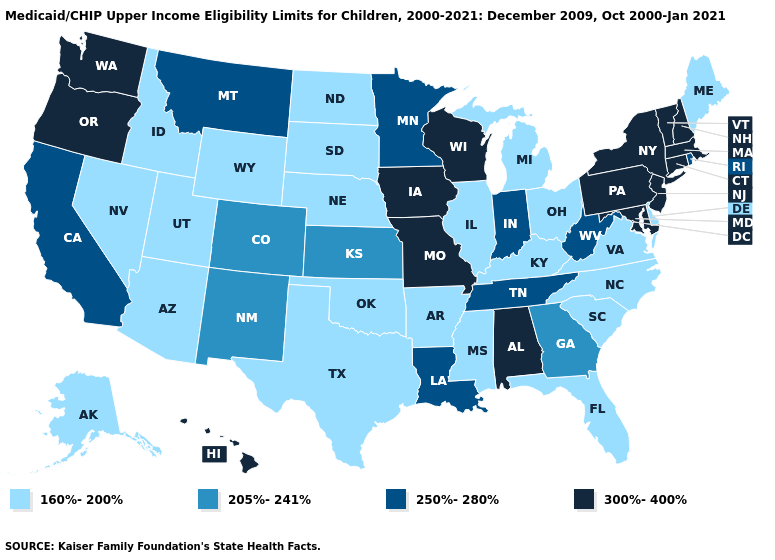Which states have the highest value in the USA?
Write a very short answer. Alabama, Connecticut, Hawaii, Iowa, Maryland, Massachusetts, Missouri, New Hampshire, New Jersey, New York, Oregon, Pennsylvania, Vermont, Washington, Wisconsin. Among the states that border Nevada , does California have the highest value?
Short answer required. No. What is the value of California?
Short answer required. 250%-280%. What is the value of Georgia?
Keep it brief. 205%-241%. What is the value of Kentucky?
Short answer required. 160%-200%. What is the lowest value in states that border Wisconsin?
Be succinct. 160%-200%. Does New Jersey have the lowest value in the Northeast?
Give a very brief answer. No. What is the value of Ohio?
Write a very short answer. 160%-200%. Among the states that border Iowa , which have the lowest value?
Keep it brief. Illinois, Nebraska, South Dakota. Does New Hampshire have the same value as Pennsylvania?
Write a very short answer. Yes. What is the value of Wisconsin?
Keep it brief. 300%-400%. Does New Hampshire have the lowest value in the USA?
Answer briefly. No. Name the states that have a value in the range 300%-400%?
Concise answer only. Alabama, Connecticut, Hawaii, Iowa, Maryland, Massachusetts, Missouri, New Hampshire, New Jersey, New York, Oregon, Pennsylvania, Vermont, Washington, Wisconsin. What is the highest value in the USA?
Short answer required. 300%-400%. What is the lowest value in states that border Tennessee?
Give a very brief answer. 160%-200%. 